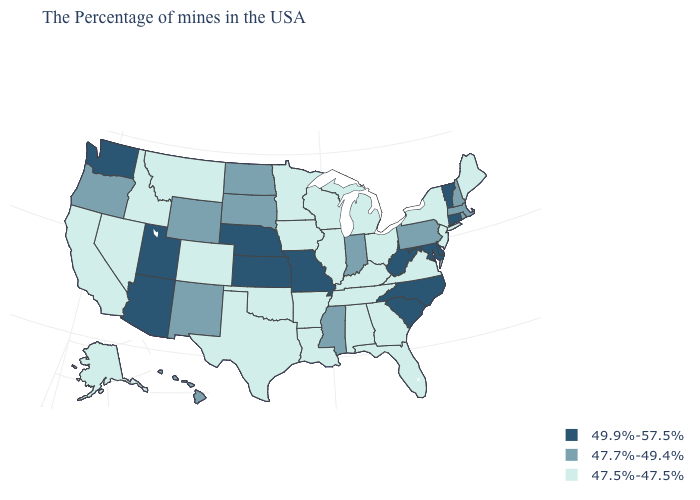Which states have the lowest value in the USA?
Short answer required. Maine, New York, New Jersey, Virginia, Ohio, Florida, Georgia, Michigan, Kentucky, Alabama, Tennessee, Wisconsin, Illinois, Louisiana, Arkansas, Minnesota, Iowa, Oklahoma, Texas, Colorado, Montana, Idaho, Nevada, California, Alaska. How many symbols are there in the legend?
Keep it brief. 3. What is the value of Michigan?
Give a very brief answer. 47.5%-47.5%. Name the states that have a value in the range 47.7%-49.4%?
Concise answer only. Massachusetts, Rhode Island, New Hampshire, Pennsylvania, Indiana, Mississippi, South Dakota, North Dakota, Wyoming, New Mexico, Oregon, Hawaii. What is the value of Virginia?
Give a very brief answer. 47.5%-47.5%. What is the lowest value in states that border Rhode Island?
Keep it brief. 47.7%-49.4%. How many symbols are there in the legend?
Short answer required. 3. Which states have the highest value in the USA?
Concise answer only. Vermont, Connecticut, Delaware, Maryland, North Carolina, South Carolina, West Virginia, Missouri, Kansas, Nebraska, Utah, Arizona, Washington. Name the states that have a value in the range 47.5%-47.5%?
Keep it brief. Maine, New York, New Jersey, Virginia, Ohio, Florida, Georgia, Michigan, Kentucky, Alabama, Tennessee, Wisconsin, Illinois, Louisiana, Arkansas, Minnesota, Iowa, Oklahoma, Texas, Colorado, Montana, Idaho, Nevada, California, Alaska. Does Mississippi have the highest value in the South?
Keep it brief. No. Does the map have missing data?
Concise answer only. No. What is the value of Oregon?
Concise answer only. 47.7%-49.4%. Name the states that have a value in the range 49.9%-57.5%?
Give a very brief answer. Vermont, Connecticut, Delaware, Maryland, North Carolina, South Carolina, West Virginia, Missouri, Kansas, Nebraska, Utah, Arizona, Washington. Name the states that have a value in the range 47.7%-49.4%?
Give a very brief answer. Massachusetts, Rhode Island, New Hampshire, Pennsylvania, Indiana, Mississippi, South Dakota, North Dakota, Wyoming, New Mexico, Oregon, Hawaii. What is the value of Arizona?
Answer briefly. 49.9%-57.5%. 